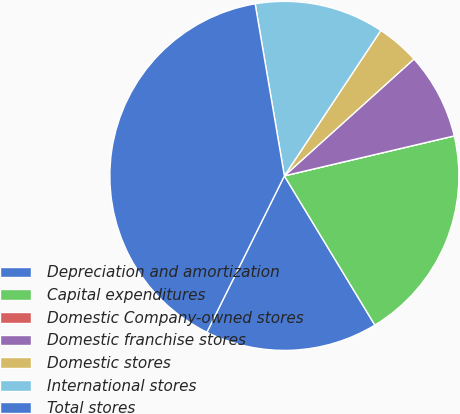Convert chart. <chart><loc_0><loc_0><loc_500><loc_500><pie_chart><fcel>Depreciation and amortization<fcel>Capital expenditures<fcel>Domestic Company-owned stores<fcel>Domestic franchise stores<fcel>Domestic stores<fcel>International stores<fcel>Total stores<nl><fcel>16.0%<fcel>20.0%<fcel>0.0%<fcel>8.0%<fcel>4.0%<fcel>12.0%<fcel>40.0%<nl></chart> 